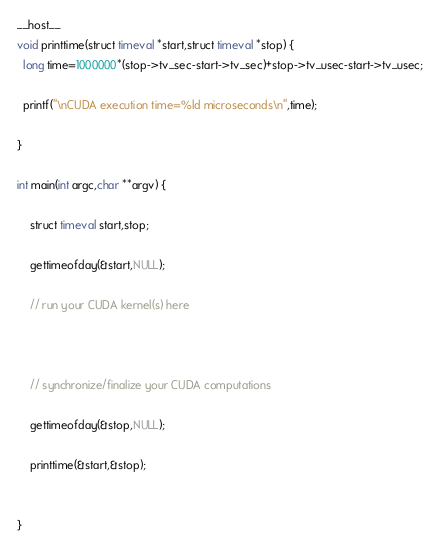Convert code to text. <code><loc_0><loc_0><loc_500><loc_500><_Cuda_>

__host__
void printtime(struct timeval *start,struct timeval *stop) {
  long time=1000000*(stop->tv_sec-start->tv_sec)+stop->tv_usec-start->tv_usec;

  printf("\nCUDA execution time=%ld microseconds\n",time);

}

int main(int argc,char **argv) {

    struct timeval start,stop;

    gettimeofday(&start,NULL);

    // run your CUDA kernel(s) here



    // synchronize/finalize your CUDA computations

    gettimeofday(&stop,NULL);

    printtime(&start,&stop);


}
</code> 